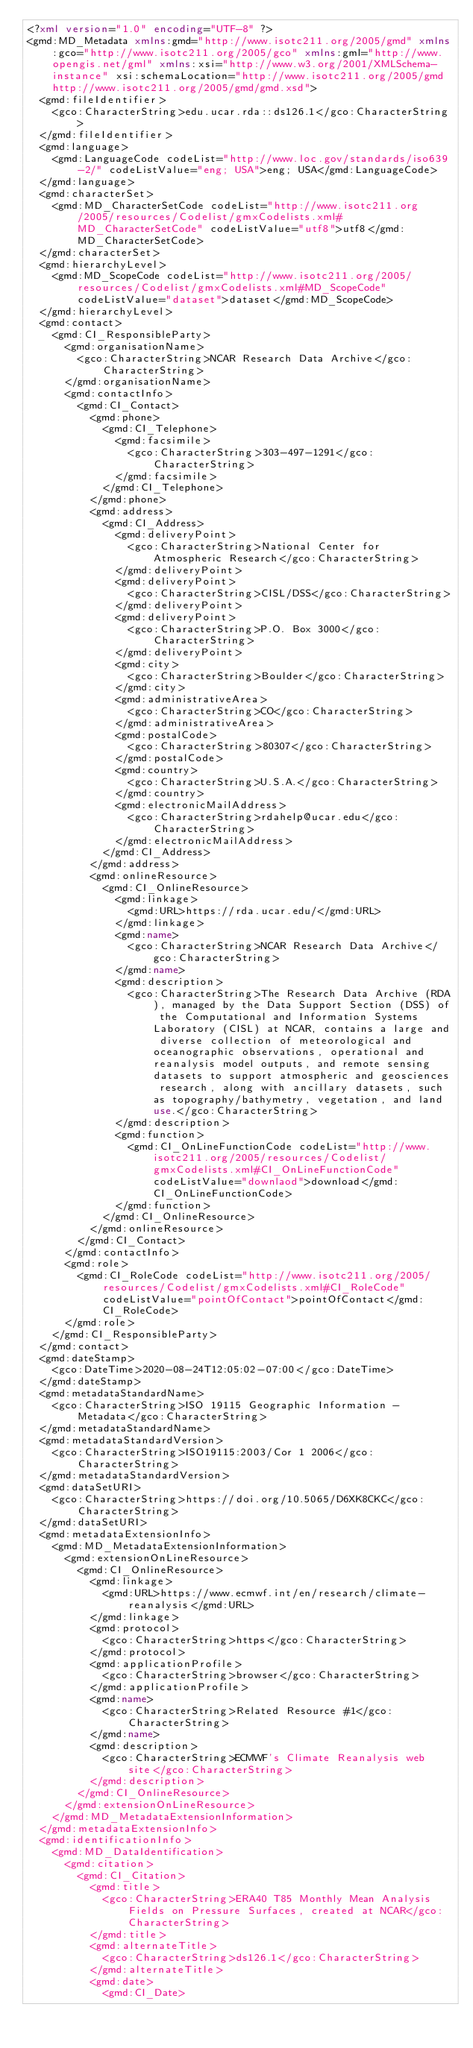<code> <loc_0><loc_0><loc_500><loc_500><_XML_><?xml version="1.0" encoding="UTF-8" ?>
<gmd:MD_Metadata xmlns:gmd="http://www.isotc211.org/2005/gmd" xmlns:gco="http://www.isotc211.org/2005/gco" xmlns:gml="http://www.opengis.net/gml" xmlns:xsi="http://www.w3.org/2001/XMLSchema-instance" xsi:schemaLocation="http://www.isotc211.org/2005/gmd http://www.isotc211.org/2005/gmd/gmd.xsd">
  <gmd:fileIdentifier>
    <gco:CharacterString>edu.ucar.rda::ds126.1</gco:CharacterString>
  </gmd:fileIdentifier>
  <gmd:language>
    <gmd:LanguageCode codeList="http://www.loc.gov/standards/iso639-2/" codeListValue="eng; USA">eng; USA</gmd:LanguageCode>
  </gmd:language>
  <gmd:characterSet>
    <gmd:MD_CharacterSetCode codeList="http://www.isotc211.org/2005/resources/Codelist/gmxCodelists.xml#MD_CharacterSetCode" codeListValue="utf8">utf8</gmd:MD_CharacterSetCode>
  </gmd:characterSet>
  <gmd:hierarchyLevel>
    <gmd:MD_ScopeCode codeList="http://www.isotc211.org/2005/resources/Codelist/gmxCodelists.xml#MD_ScopeCode" codeListValue="dataset">dataset</gmd:MD_ScopeCode>
  </gmd:hierarchyLevel>
  <gmd:contact>
    <gmd:CI_ResponsibleParty>
      <gmd:organisationName>
        <gco:CharacterString>NCAR Research Data Archive</gco:CharacterString>
      </gmd:organisationName>
      <gmd:contactInfo>
        <gmd:CI_Contact>
          <gmd:phone>
            <gmd:CI_Telephone>
              <gmd:facsimile>
                <gco:CharacterString>303-497-1291</gco:CharacterString>
              </gmd:facsimile>
            </gmd:CI_Telephone>
          </gmd:phone>
          <gmd:address>
            <gmd:CI_Address>
              <gmd:deliveryPoint>
                <gco:CharacterString>National Center for Atmospheric Research</gco:CharacterString>
              </gmd:deliveryPoint>
              <gmd:deliveryPoint>
                <gco:CharacterString>CISL/DSS</gco:CharacterString>
              </gmd:deliveryPoint>
              <gmd:deliveryPoint>
                <gco:CharacterString>P.O. Box 3000</gco:CharacterString>
              </gmd:deliveryPoint>
              <gmd:city>
                <gco:CharacterString>Boulder</gco:CharacterString>
              </gmd:city>
              <gmd:administrativeArea>
                <gco:CharacterString>CO</gco:CharacterString>
              </gmd:administrativeArea>
              <gmd:postalCode>
                <gco:CharacterString>80307</gco:CharacterString>
              </gmd:postalCode>
              <gmd:country>
                <gco:CharacterString>U.S.A.</gco:CharacterString>
              </gmd:country>
              <gmd:electronicMailAddress>
                <gco:CharacterString>rdahelp@ucar.edu</gco:CharacterString>
              </gmd:electronicMailAddress>
            </gmd:CI_Address>
          </gmd:address>
          <gmd:onlineResource>
            <gmd:CI_OnlineResource>
              <gmd:linkage>
                <gmd:URL>https://rda.ucar.edu/</gmd:URL>
              </gmd:linkage>
              <gmd:name>
                <gco:CharacterString>NCAR Research Data Archive</gco:CharacterString>
              </gmd:name>
              <gmd:description>
                <gco:CharacterString>The Research Data Archive (RDA), managed by the Data Support Section (DSS) of the Computational and Information Systems Laboratory (CISL) at NCAR, contains a large and diverse collection of meteorological and oceanographic observations, operational and reanalysis model outputs, and remote sensing datasets to support atmospheric and geosciences research, along with ancillary datasets, such as topography/bathymetry, vegetation, and land use.</gco:CharacterString>
              </gmd:description>
              <gmd:function>
                <gmd:CI_OnLineFunctionCode codeList="http://www.isotc211.org/2005/resources/Codelist/gmxCodelists.xml#CI_OnLineFunctionCode" codeListValue="downlaod">download</gmd:CI_OnLineFunctionCode>
              </gmd:function>
            </gmd:CI_OnlineResource>
          </gmd:onlineResource>
        </gmd:CI_Contact>
      </gmd:contactInfo>
      <gmd:role>
        <gmd:CI_RoleCode codeList="http://www.isotc211.org/2005/resources/Codelist/gmxCodelists.xml#CI_RoleCode" codeListValue="pointOfContact">pointOfContact</gmd:CI_RoleCode>
      </gmd:role>
    </gmd:CI_ResponsibleParty>
  </gmd:contact>
  <gmd:dateStamp>
    <gco:DateTime>2020-08-24T12:05:02-07:00</gco:DateTime>
  </gmd:dateStamp>
  <gmd:metadataStandardName>
    <gco:CharacterString>ISO 19115 Geographic Information - Metadata</gco:CharacterString>
  </gmd:metadataStandardName>
  <gmd:metadataStandardVersion>
    <gco:CharacterString>ISO19115:2003/Cor 1 2006</gco:CharacterString>
  </gmd:metadataStandardVersion>
  <gmd:dataSetURI>
    <gco:CharacterString>https://doi.org/10.5065/D6XK8CKC</gco:CharacterString>
  </gmd:dataSetURI>
  <gmd:metadataExtensionInfo>
    <gmd:MD_MetadataExtensionInformation>
      <gmd:extensionOnLineResource>
        <gmd:CI_OnlineResource>
          <gmd:linkage>
            <gmd:URL>https://www.ecmwf.int/en/research/climate-reanalysis</gmd:URL>
          </gmd:linkage>
          <gmd:protocol>
            <gco:CharacterString>https</gco:CharacterString>
          </gmd:protocol>
          <gmd:applicationProfile>
            <gco:CharacterString>browser</gco:CharacterString>
          </gmd:applicationProfile>
          <gmd:name>
            <gco:CharacterString>Related Resource #1</gco:CharacterString>
          </gmd:name>
          <gmd:description>
            <gco:CharacterString>ECMWF's Climate Reanalysis web site</gco:CharacterString>
          </gmd:description>
        </gmd:CI_OnlineResource>
      </gmd:extensionOnLineResource>
    </gmd:MD_MetadataExtensionInformation>
  </gmd:metadataExtensionInfo>
  <gmd:identificationInfo>
    <gmd:MD_DataIdentification>
      <gmd:citation>
        <gmd:CI_Citation>
          <gmd:title>
            <gco:CharacterString>ERA40 T85 Monthly Mean Analysis Fields on Pressure Surfaces, created at NCAR</gco:CharacterString>
          </gmd:title>
          <gmd:alternateTitle>
            <gco:CharacterString>ds126.1</gco:CharacterString>
          </gmd:alternateTitle>
          <gmd:date>
            <gmd:CI_Date></code> 